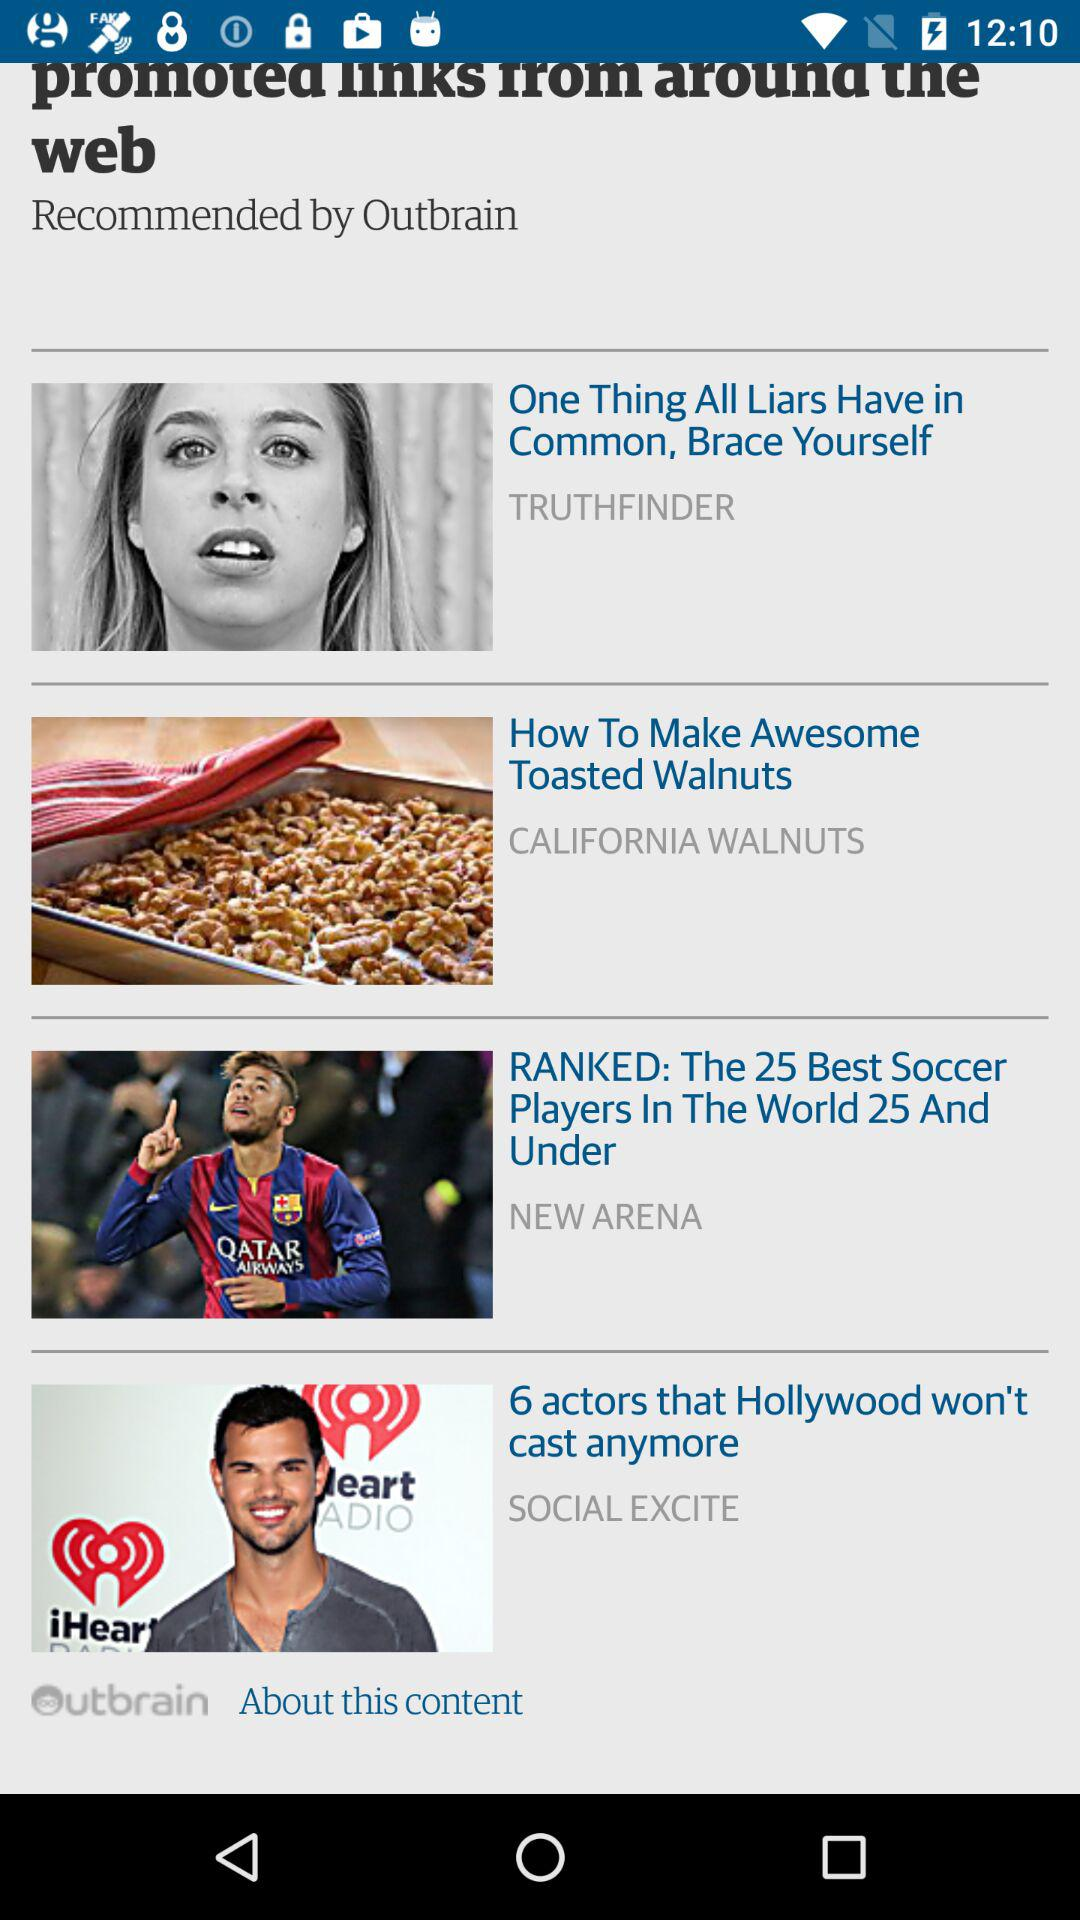How many promoted links are there on this screen?
Answer the question using a single word or phrase. 4 